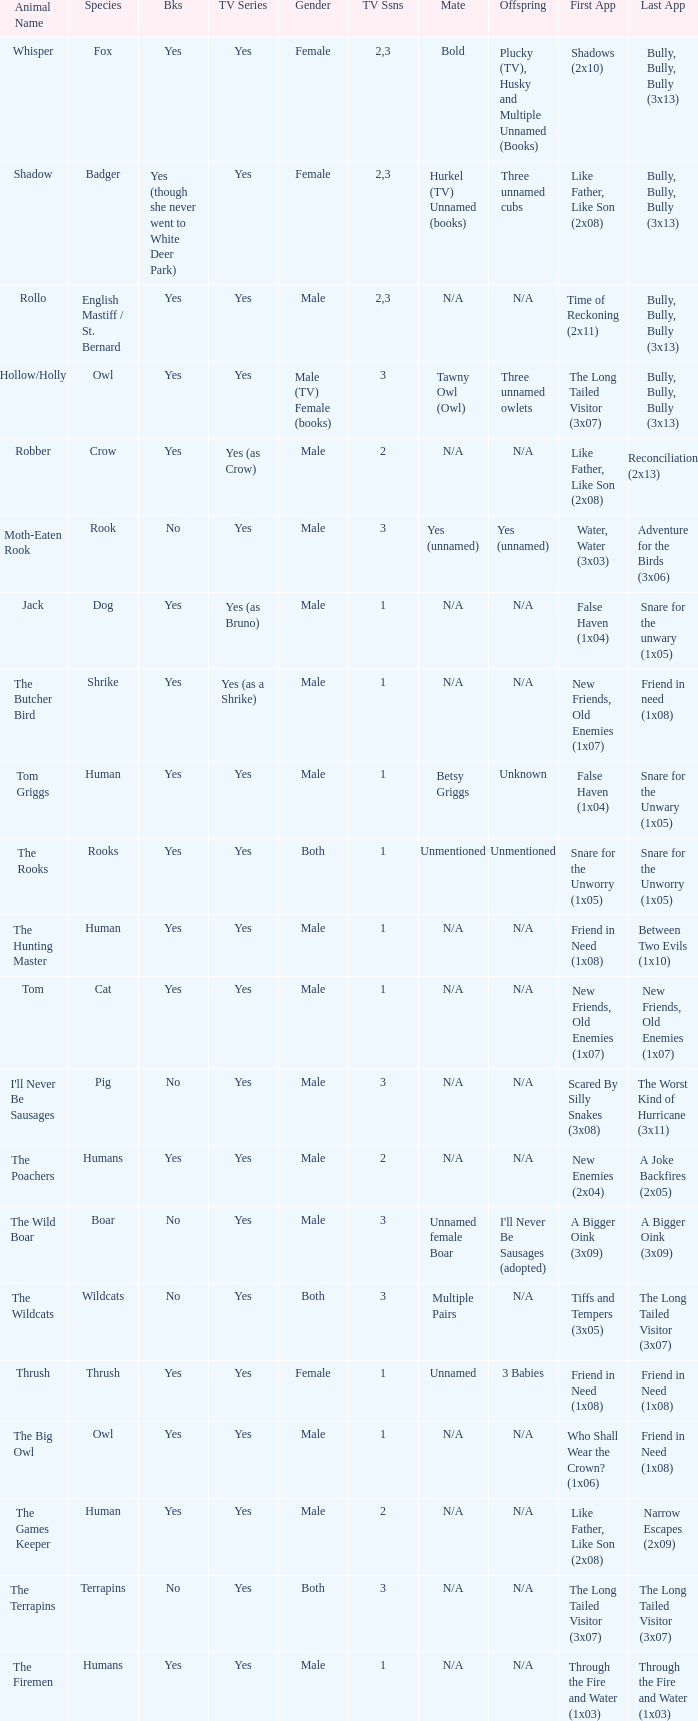In a tv series with human species and a 'yes' element, which season has the least number of episodes? 1.0. 